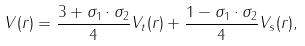<formula> <loc_0><loc_0><loc_500><loc_500>V ( r ) = \frac { 3 + \sigma _ { 1 } \cdot \sigma _ { 2 } } { 4 } V _ { t } ( r ) + \frac { 1 - \sigma _ { 1 } \cdot \sigma _ { 2 } } { 4 } V _ { s } ( r ) ,</formula> 